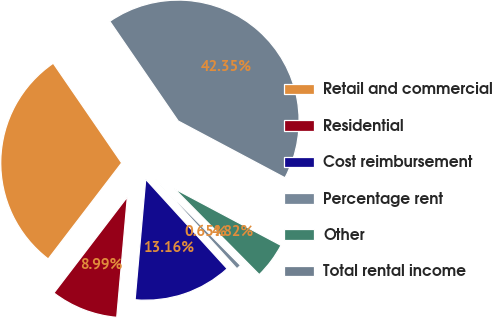<chart> <loc_0><loc_0><loc_500><loc_500><pie_chart><fcel>Retail and commercial<fcel>Residential<fcel>Cost reimbursement<fcel>Percentage rent<fcel>Other<fcel>Total rental income<nl><fcel>30.04%<fcel>8.99%<fcel>13.16%<fcel>0.65%<fcel>4.82%<fcel>42.35%<nl></chart> 